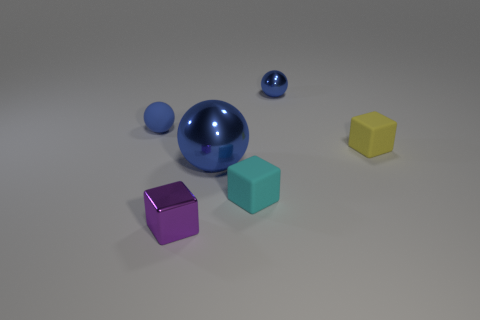There is a large blue shiny object; what shape is it?
Ensure brevity in your answer.  Sphere. Are there more small blue metal balls that are left of the tiny cyan cube than tiny objects?
Ensure brevity in your answer.  No. Is there anything else that is the same shape as the small blue matte thing?
Ensure brevity in your answer.  Yes. There is a tiny shiny thing that is the same shape as the large blue thing; what is its color?
Make the answer very short. Blue. There is a tiny object behind the blue matte object; what shape is it?
Make the answer very short. Sphere. There is a small purple shiny block; are there any tiny blue metallic spheres on the left side of it?
Your response must be concise. No. Is there any other thing that has the same size as the purple object?
Provide a short and direct response. Yes. There is a small sphere that is made of the same material as the yellow object; what color is it?
Your answer should be compact. Blue. There is a small shiny thing right of the metal cube; does it have the same color as the sphere on the left side of the big blue metallic ball?
Ensure brevity in your answer.  Yes. What number of blocks are either cyan rubber objects or cyan metallic things?
Your response must be concise. 1. 